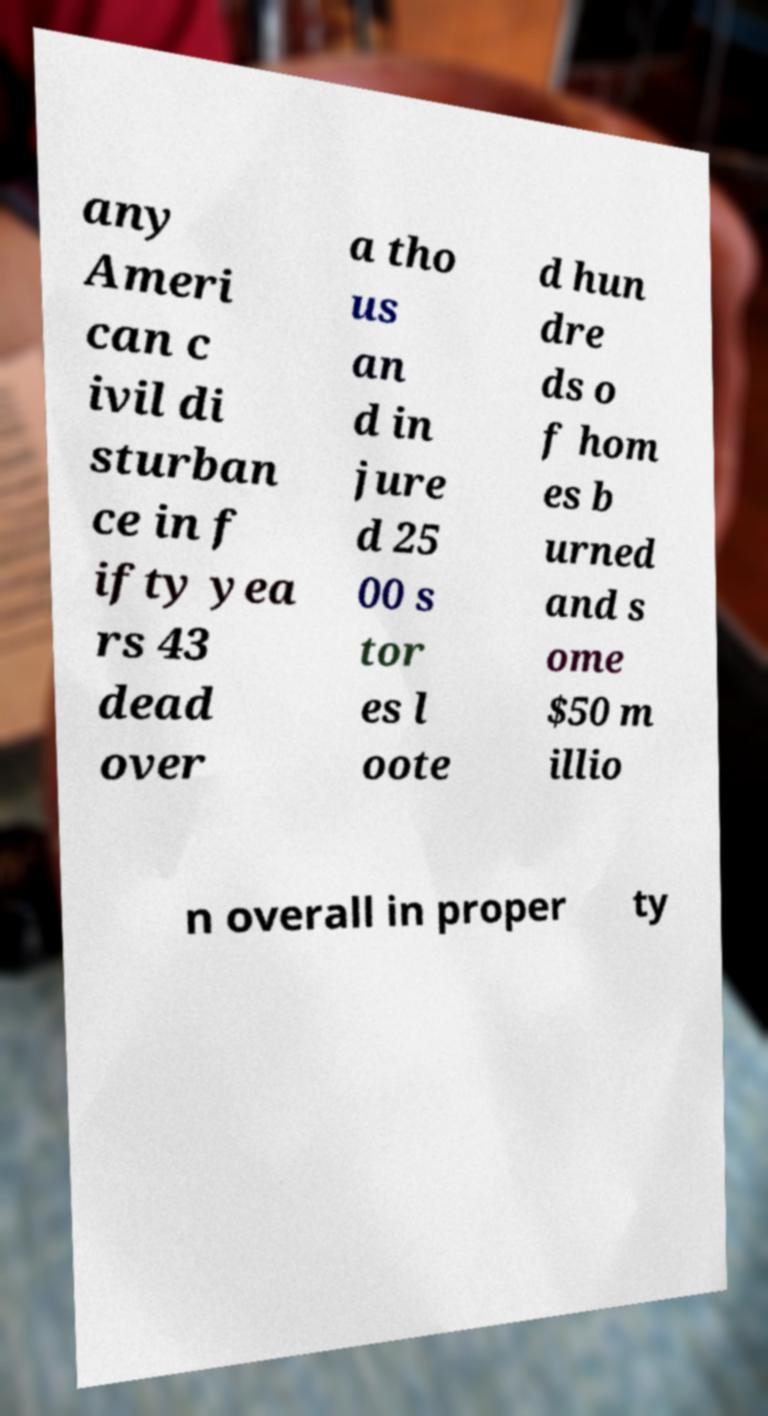Please read and relay the text visible in this image. What does it say? any Ameri can c ivil di sturban ce in f ifty yea rs 43 dead over a tho us an d in jure d 25 00 s tor es l oote d hun dre ds o f hom es b urned and s ome $50 m illio n overall in proper ty 